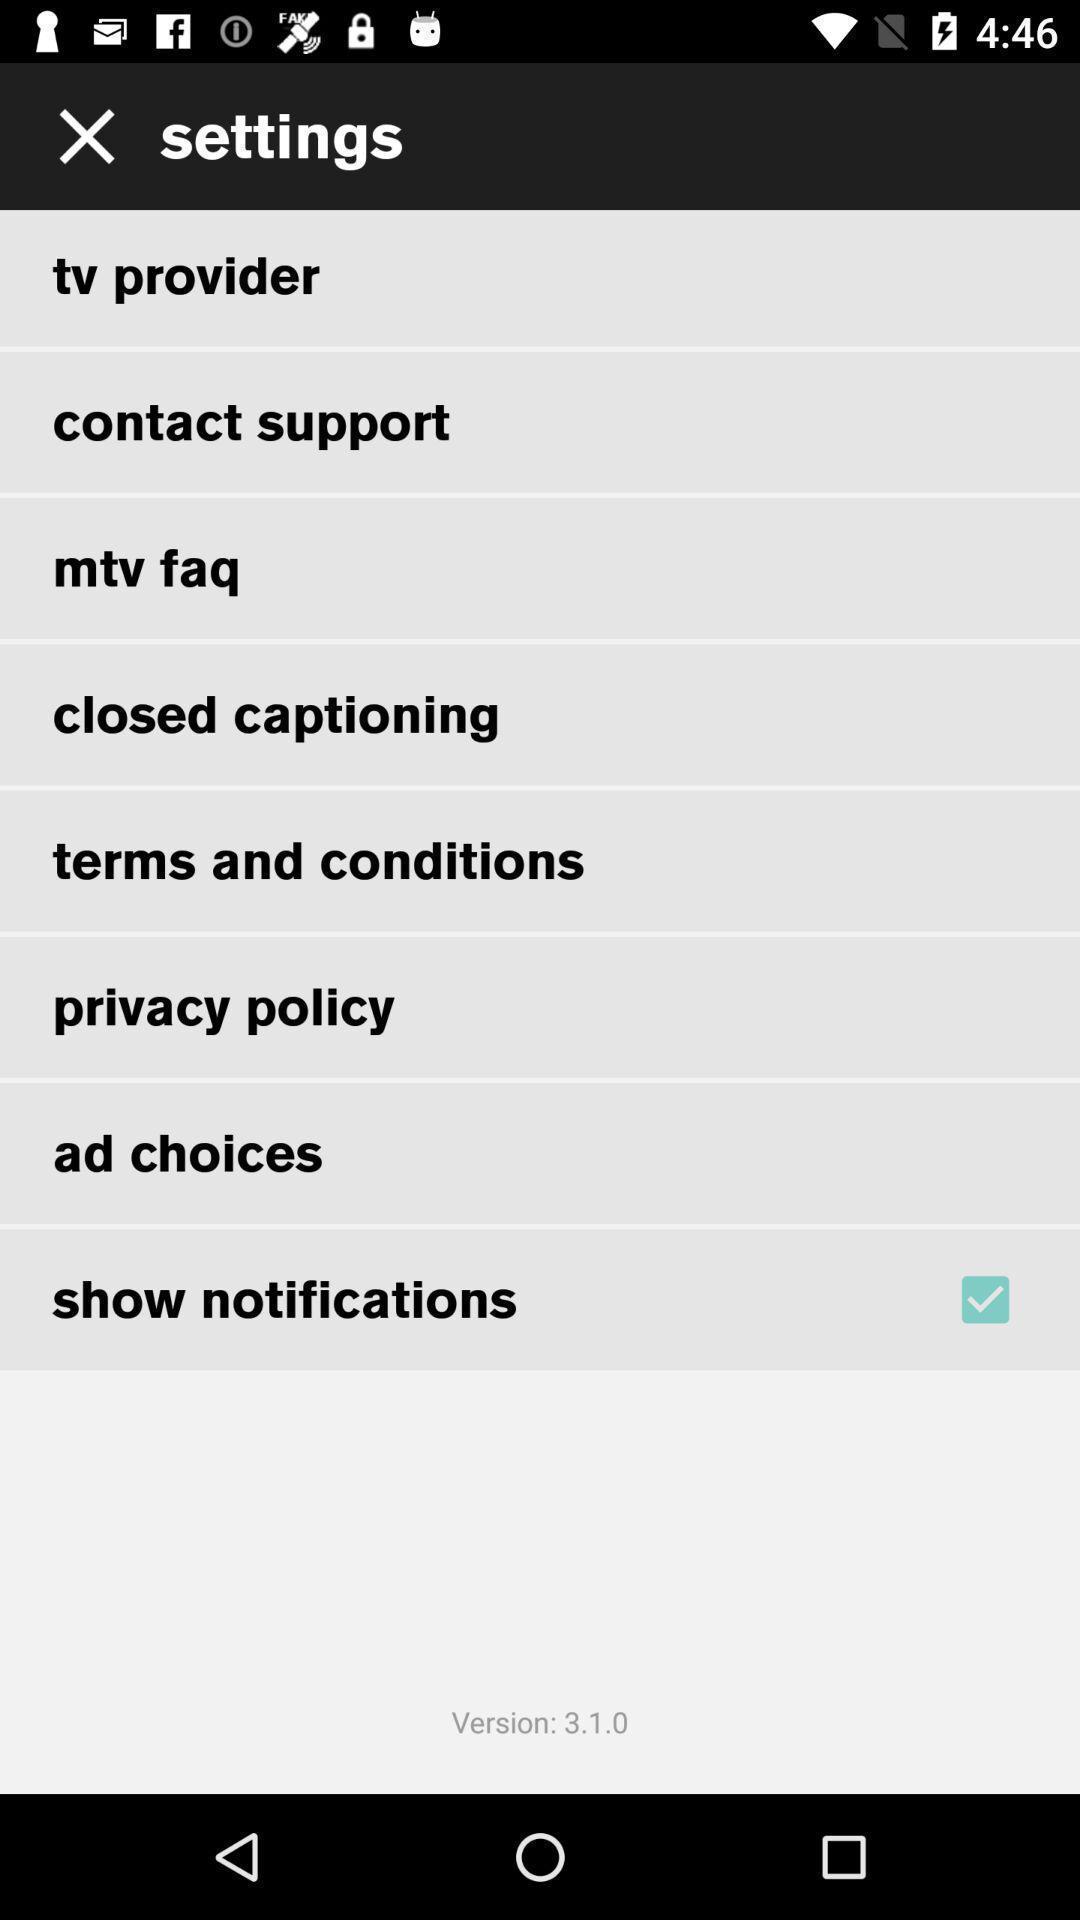Describe the visual elements of this screenshot. Settings page with various options. 